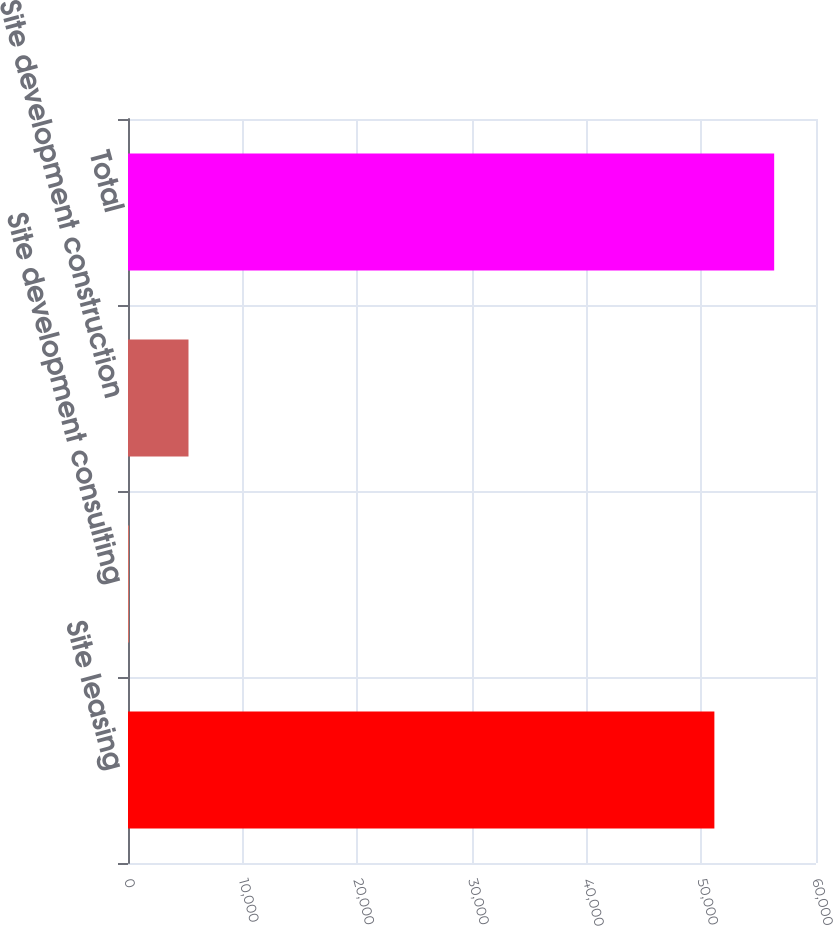Convert chart. <chart><loc_0><loc_0><loc_500><loc_500><bar_chart><fcel>Site leasing<fcel>Site development consulting<fcel>Site development construction<fcel>Total<nl><fcel>51138<fcel>61<fcel>5275.6<fcel>56352.6<nl></chart> 